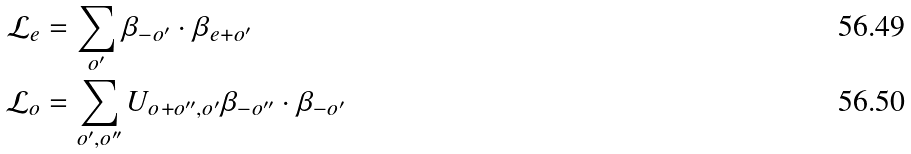<formula> <loc_0><loc_0><loc_500><loc_500>\mathcal { L } _ { e } & = \sum _ { o ^ { \prime } } \beta _ { - o ^ { \prime } } \cdot \beta _ { e + o ^ { \prime } } \\ \mathcal { L } _ { o } & = \sum _ { o ^ { \prime } , o ^ { \prime \prime } } U _ { o + o ^ { \prime \prime } , o ^ { \prime } } \beta _ { - o ^ { \prime \prime } } \cdot \beta _ { - o ^ { \prime } } \,</formula> 